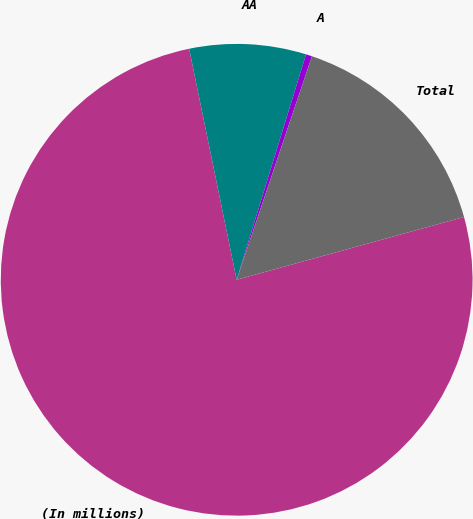Convert chart. <chart><loc_0><loc_0><loc_500><loc_500><pie_chart><fcel>(In millions)<fcel>AA<fcel>A<fcel>Total<nl><fcel>76.06%<fcel>7.98%<fcel>0.42%<fcel>15.54%<nl></chart> 